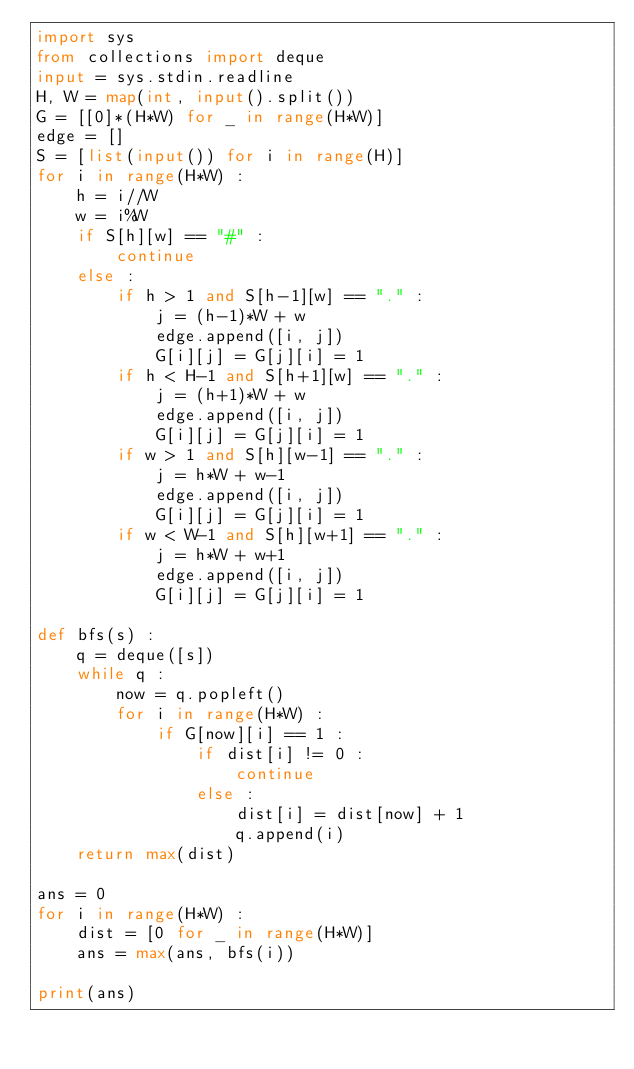<code> <loc_0><loc_0><loc_500><loc_500><_Python_>import sys
from collections import deque
input = sys.stdin.readline
H, W = map(int, input().split())
G = [[0]*(H*W) for _ in range(H*W)]
edge = []
S = [list(input()) for i in range(H)]
for i in range(H*W) :
    h = i//W
    w = i%W
    if S[h][w] == "#" :
        continue
    else :
        if h > 1 and S[h-1][w] == "." :
            j = (h-1)*W + w
            edge.append([i, j])
            G[i][j] = G[j][i] = 1
        if h < H-1 and S[h+1][w] == "." :
            j = (h+1)*W + w
            edge.append([i, j])
            G[i][j] = G[j][i] = 1
        if w > 1 and S[h][w-1] == "." :
            j = h*W + w-1
            edge.append([i, j])
            G[i][j] = G[j][i] = 1
        if w < W-1 and S[h][w+1] == "." :
            j = h*W + w+1
            edge.append([i, j])
            G[i][j] = G[j][i] = 1

def bfs(s) :
    q = deque([s])
    while q :
        now = q.popleft()
        for i in range(H*W) :
            if G[now][i] == 1 :
                if dist[i] != 0 :
                    continue
                else :
                    dist[i] = dist[now] + 1
                    q.append(i)
    return max(dist)

ans = 0
for i in range(H*W) :
    dist = [0 for _ in range(H*W)]
    ans = max(ans, bfs(i))

print(ans)</code> 